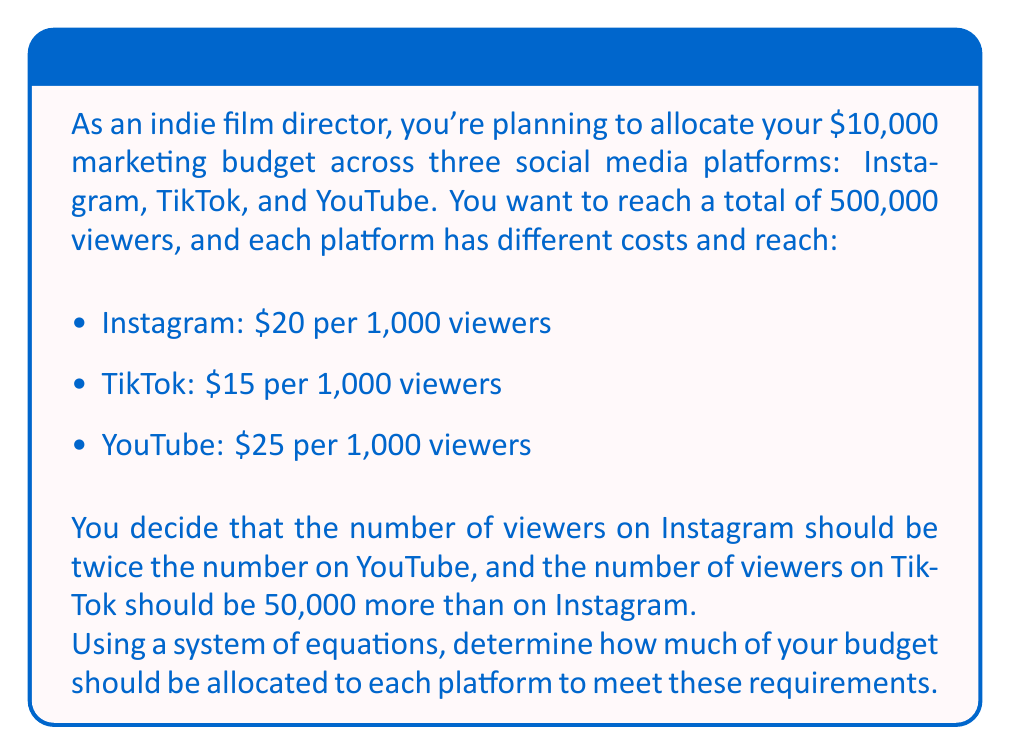Give your solution to this math problem. Let's solve this problem step by step using a system of equations:

1. Define variables:
   Let $x$ = number of viewers on YouTube (in thousands)
   Let $y$ = number of viewers on Instagram (in thousands)
   Let $z$ = number of viewers on TikTok (in thousands)

2. Set up equations based on the given information:
   Total viewers: $x + y + z = 500$ (Equation 1)
   Budget constraint: $25x + 20y + 15z = 10000$ (Equation 2)
   Instagram viewers: $y = 2x$ (Equation 3)
   TikTok viewers: $z = y + 50$ (Equation 4)

3. Substitute Equation 3 into Equation 1 and Equation 4:
   $x + 2x + (2x + 50) = 500$
   $5x + 50 = 500$
   $5x = 450$
   $x = 90$

4. Calculate $y$ and $z$ using Equations 3 and 4:
   $y = 2x = 2(90) = 180$
   $z = y + 50 = 180 + 50 = 230$

5. Verify the total number of viewers:
   $90 + 180 + 230 = 500$ thousand viewers (correct)

6. Calculate the budget allocation for each platform:
   YouTube: $25 * 90 = $2,250
   Instagram: $20 * 180 = $3,600
   TikTok: $15 * 230 = $3,450

7. Verify the total budget:
   $2,250 + $3,600 + $3,450 = $9,300 (which is within the $10,000 budget)
Answer: YouTube: $2,250; Instagram: $3,600; TikTok: $3,450 